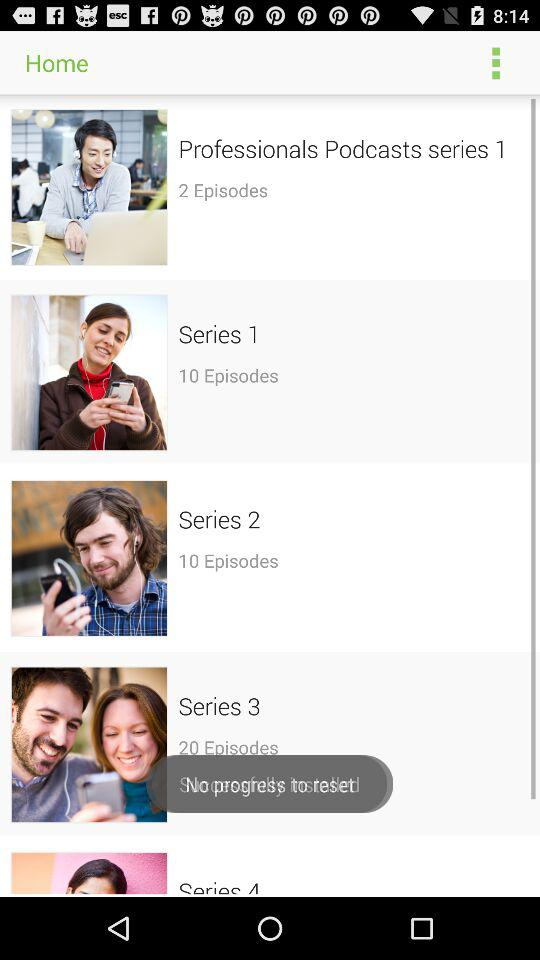How many episodes are there in "Series 1"? There are 10 episodes. 